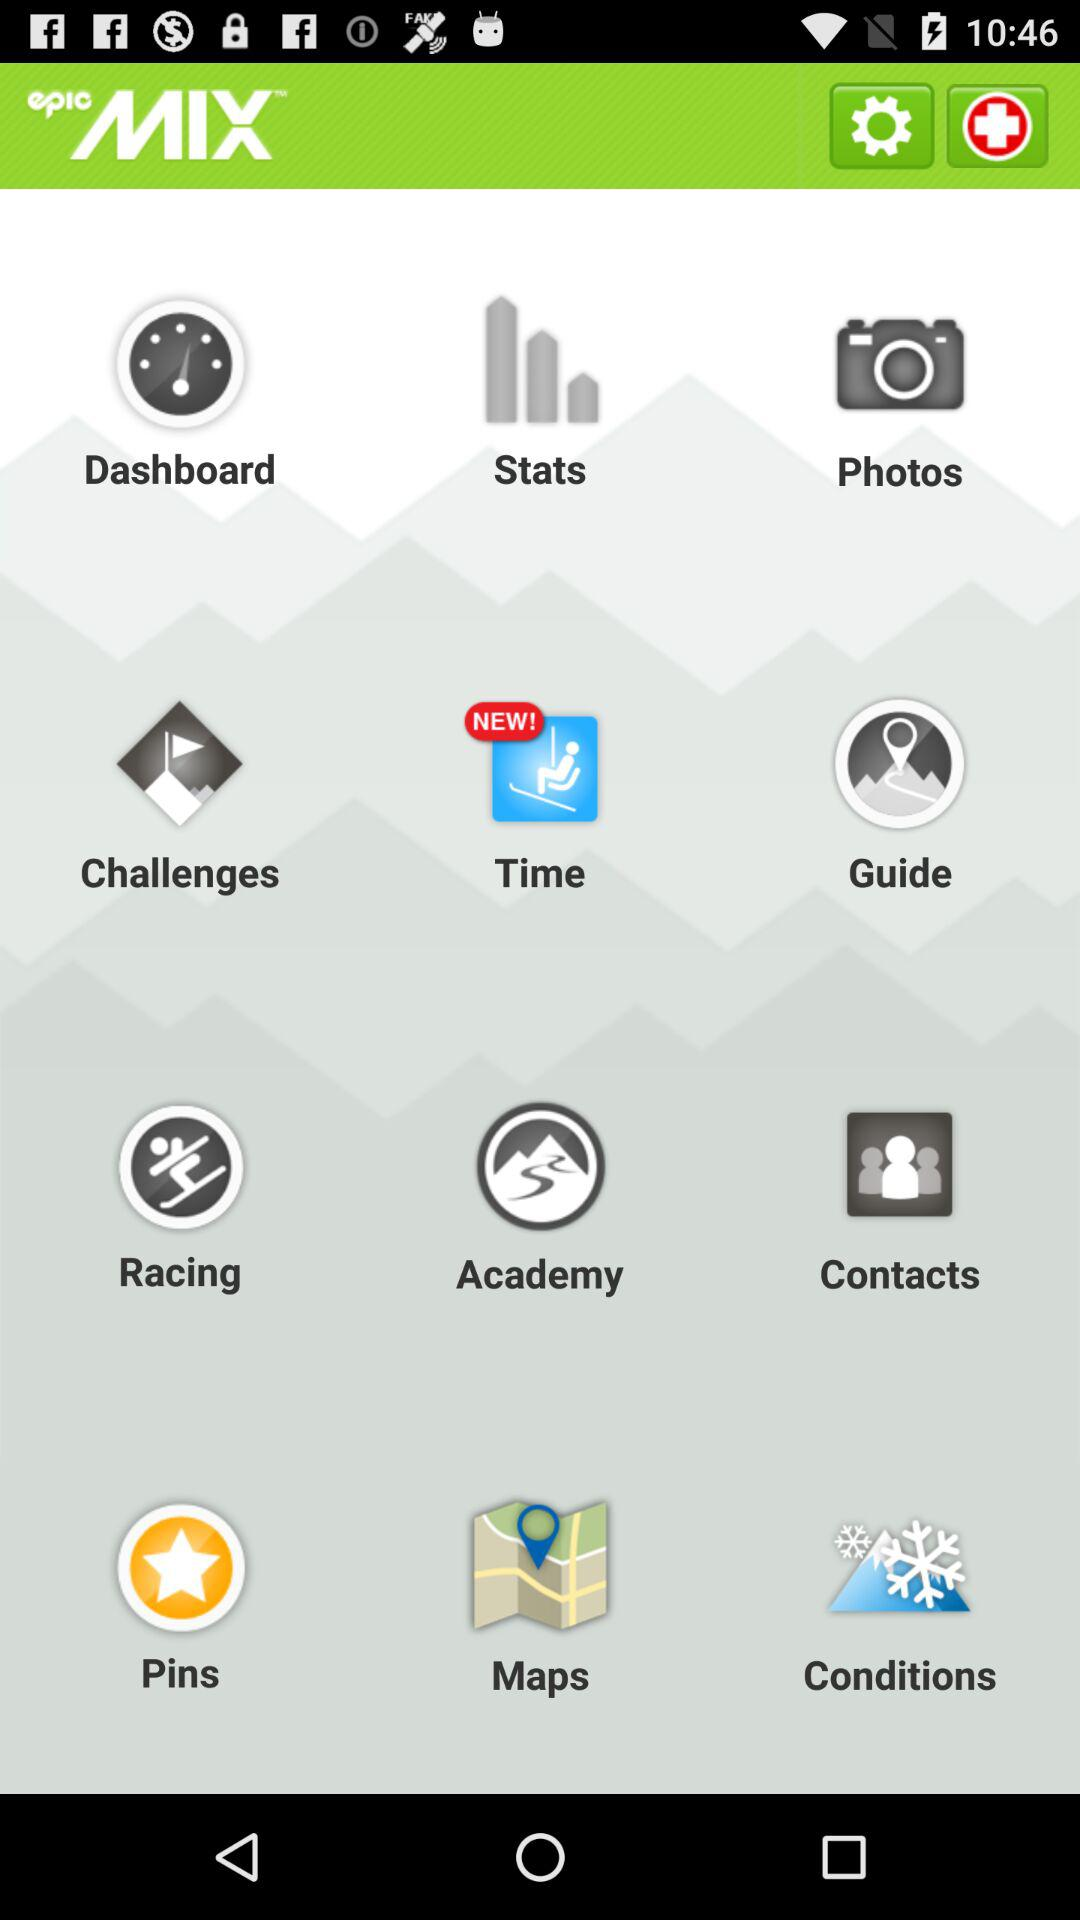What is the name of the application? The name of the application is "epicMIX". 